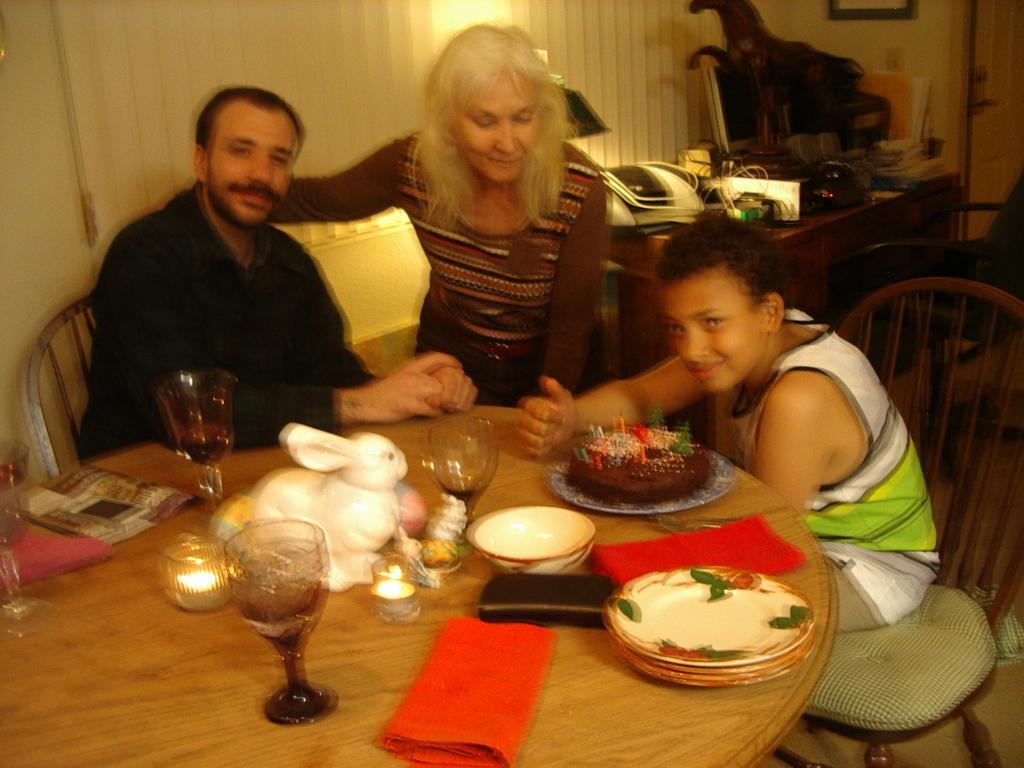Please provide a concise description of this image. It is a room inside the house, there is a table and there are three people around the table a boy, a woman and a man there are three glasses, a toy , a napkin,plates and cake and few candles on the table. Behind them there are some electronic gadgets placed on the table and also a statue, in the background there is a curtain, a light and a wall, and also a door. 